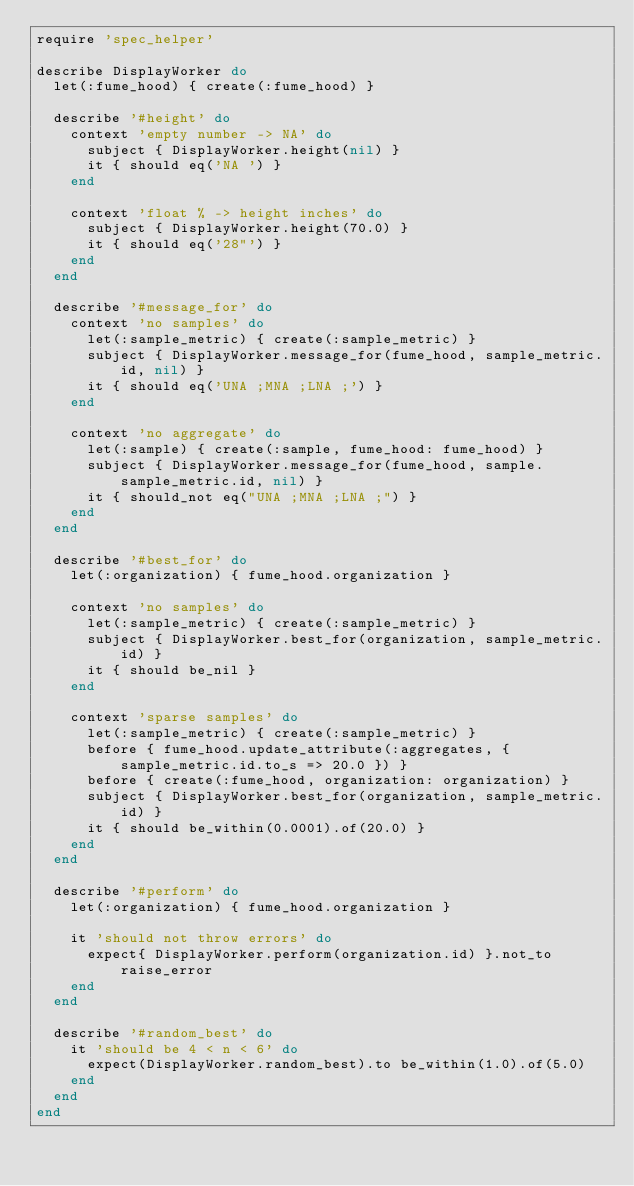Convert code to text. <code><loc_0><loc_0><loc_500><loc_500><_Ruby_>require 'spec_helper'

describe DisplayWorker do  
  let(:fume_hood) { create(:fume_hood) }
  
  describe '#height' do
    context 'empty number -> NA' do
      subject { DisplayWorker.height(nil) }
      it { should eq('NA ') }
    end
    
    context 'float % -> height inches' do
      subject { DisplayWorker.height(70.0) }
      it { should eq('28"') }
    end
  end
  
  describe '#message_for' do    
    context 'no samples' do
      let(:sample_metric) { create(:sample_metric) }
      subject { DisplayWorker.message_for(fume_hood, sample_metric.id, nil) }
      it { should eq('UNA ;MNA ;LNA ;') }
    end
    
    context 'no aggregate' do
      let(:sample) { create(:sample, fume_hood: fume_hood) }
      subject { DisplayWorker.message_for(fume_hood, sample.sample_metric.id, nil) }
      it { should_not eq("UNA ;MNA ;LNA ;") }
    end
  end
  
  describe '#best_for' do
    let(:organization) { fume_hood.organization }
    
    context 'no samples' do
      let(:sample_metric) { create(:sample_metric) }
      subject { DisplayWorker.best_for(organization, sample_metric.id) }
      it { should be_nil }
    end
    
    context 'sparse samples' do
      let(:sample_metric) { create(:sample_metric) }
      before { fume_hood.update_attribute(:aggregates, { sample_metric.id.to_s => 20.0 }) }
      before { create(:fume_hood, organization: organization) }
      subject { DisplayWorker.best_for(organization, sample_metric.id) }
      it { should be_within(0.0001).of(20.0) }
    end
  end
  
  describe '#perform' do
    let(:organization) { fume_hood.organization }
    
    it 'should not throw errors' do
      expect{ DisplayWorker.perform(organization.id) }.not_to raise_error
    end
  end
	
	describe '#random_best' do
		it 'should be 4 < n < 6' do
			expect(DisplayWorker.random_best).to be_within(1.0).of(5.0)
		end
	end
end</code> 